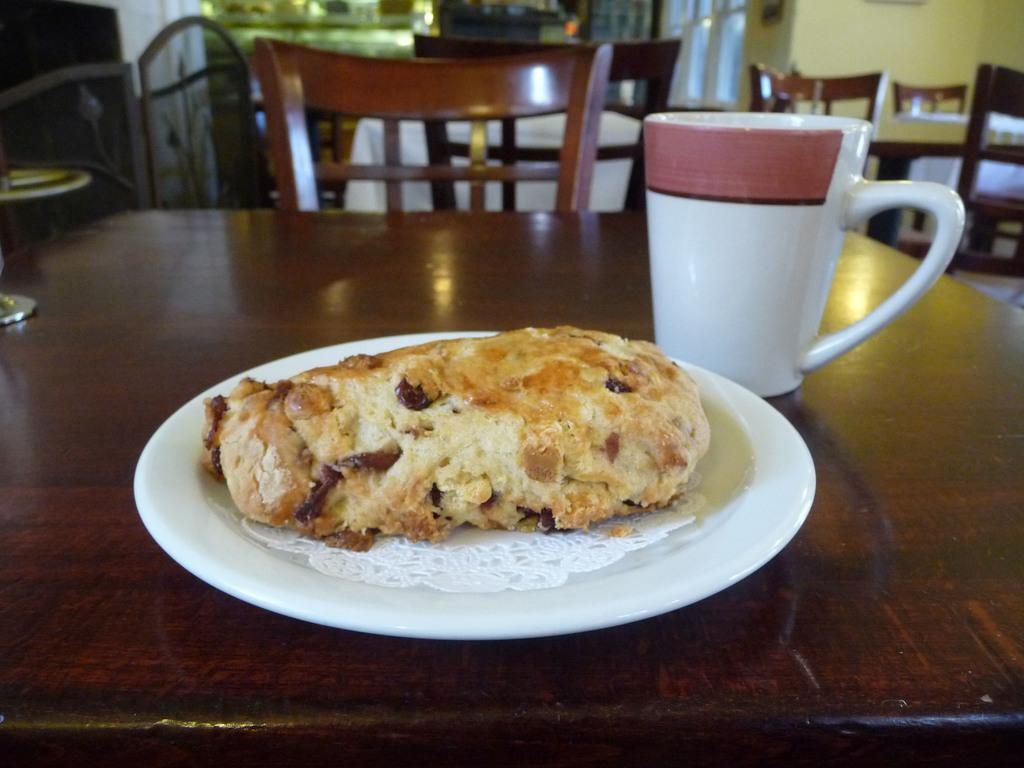What type of structure can be seen in the image? There is a wall in the image. What type of furniture is present in the image? There are chairs and a table in the image. What is placed on the table in the image? There is a plate and a cup on the table in the image. What is on the plate in the image? There is a food item on the plate in the image. What is the topic of the discussion taking place in the image? There is no discussion taking place in the image; it is a still image of a wall, chairs, table, plate, and cup. How many bits of the food item can be seen on the plate in the image? There is no indication of the food item being composed of bits, and the image does not provide a close-up view of the food item to count any such bits. 